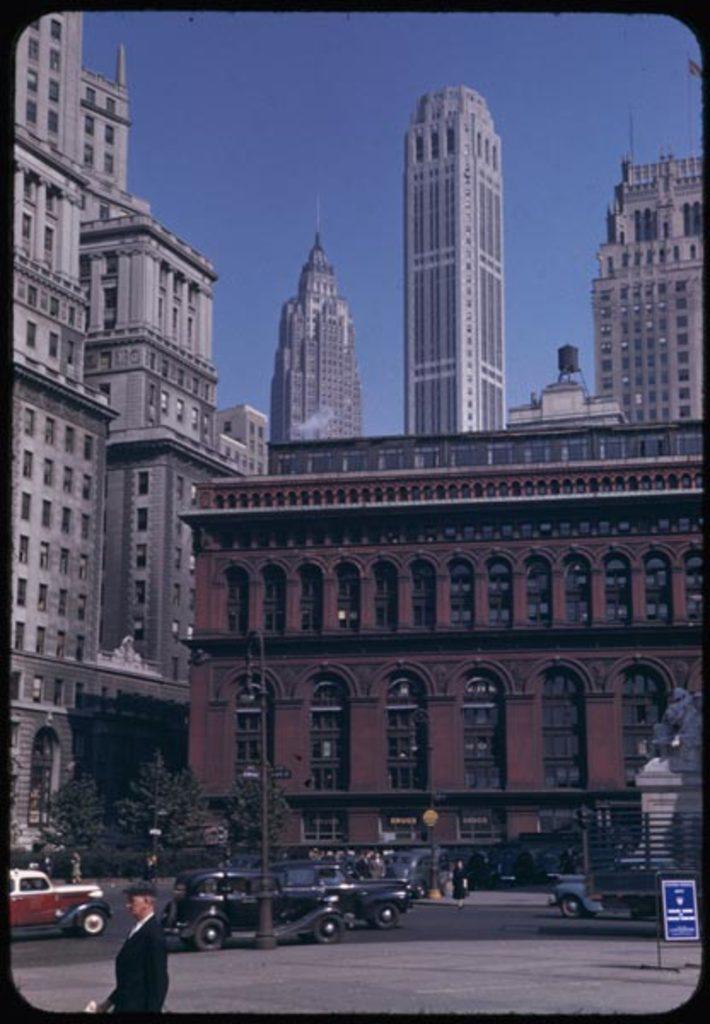Could you give a brief overview of what you see in this image? In this image, we can see some buildings, trees, poles, vehicles, people. We can see the ground. We can also a board, a statue and the sky. 